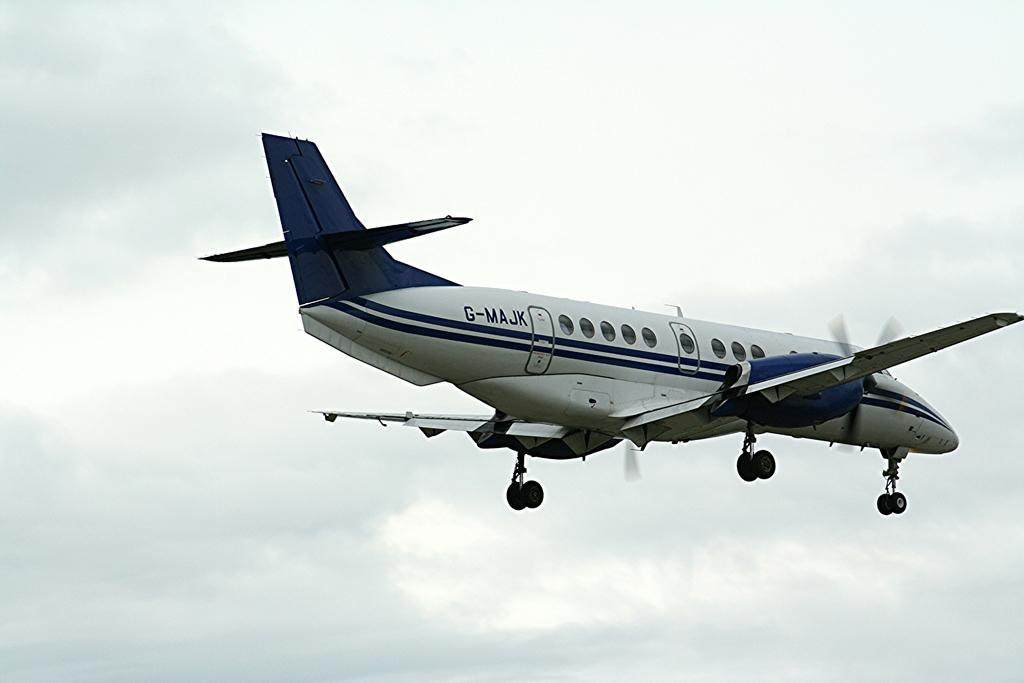<image>
Provide a brief description of the given image. a plane that says 'gmajk' on the side of it 